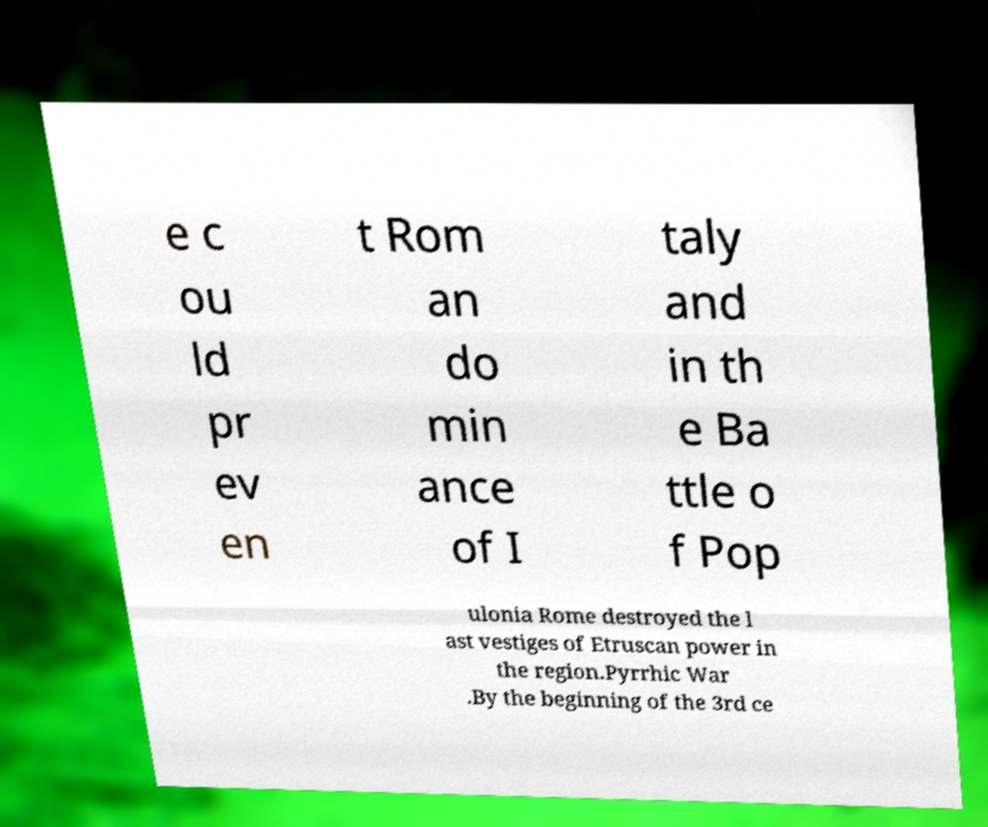For documentation purposes, I need the text within this image transcribed. Could you provide that? e c ou ld pr ev en t Rom an do min ance of I taly and in th e Ba ttle o f Pop ulonia Rome destroyed the l ast vestiges of Etruscan power in the region.Pyrrhic War .By the beginning of the 3rd ce 